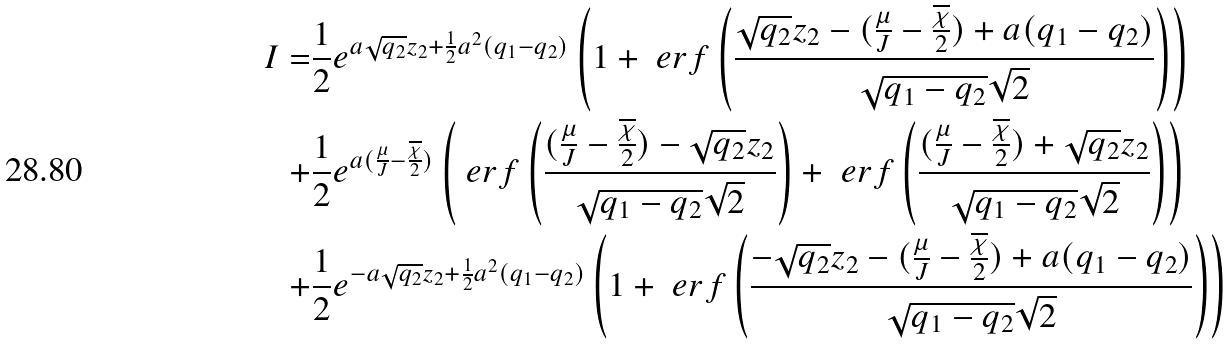Convert formula to latex. <formula><loc_0><loc_0><loc_500><loc_500>I = & \frac { 1 } { 2 } e ^ { a \sqrt { q _ { 2 } } z _ { 2 } + \frac { 1 } { 2 } a ^ { 2 } ( q _ { 1 } - q _ { 2 } ) } \left ( 1 + \ e r f \left ( \frac { \sqrt { q _ { 2 } } z _ { 2 } - ( \frac { \mu } { J } - \frac { \overline { \chi } } { 2 } ) + a ( q _ { 1 } - q _ { 2 } ) } { \sqrt { q _ { 1 } - q _ { 2 } } \sqrt { 2 } } \right ) \right ) \\ + & \frac { 1 } { 2 } e ^ { a ( \frac { \mu } { J } - \frac { \overline { \chi } } { 2 } ) } \left ( \ e r f \left ( \frac { ( \frac { \mu } { J } - \frac { \overline { \chi } } { 2 } ) - \sqrt { q _ { 2 } } z _ { 2 } } { \sqrt { q _ { 1 } - q _ { 2 } } \sqrt { 2 } } \right ) + \ e r f \left ( \frac { ( \frac { \mu } { J } - \frac { \overline { \chi } } { 2 } ) + \sqrt { q _ { 2 } } z _ { 2 } } { \sqrt { q _ { 1 } - q _ { 2 } } \sqrt { 2 } } \right ) \right ) \\ + & \frac { 1 } { 2 } e ^ { - a \sqrt { q _ { 2 } } z _ { 2 } + \frac { 1 } { 2 } a ^ { 2 } ( q _ { 1 } - q _ { 2 } ) } \left ( 1 + \ e r f \left ( \frac { - \sqrt { q _ { 2 } } z _ { 2 } - ( \frac { \mu } { J } - \frac { \overline { \chi } } { 2 } ) + a ( q _ { 1 } - q _ { 2 } ) } { \sqrt { q _ { 1 } - q _ { 2 } } \sqrt { 2 } } \right ) \right )</formula> 